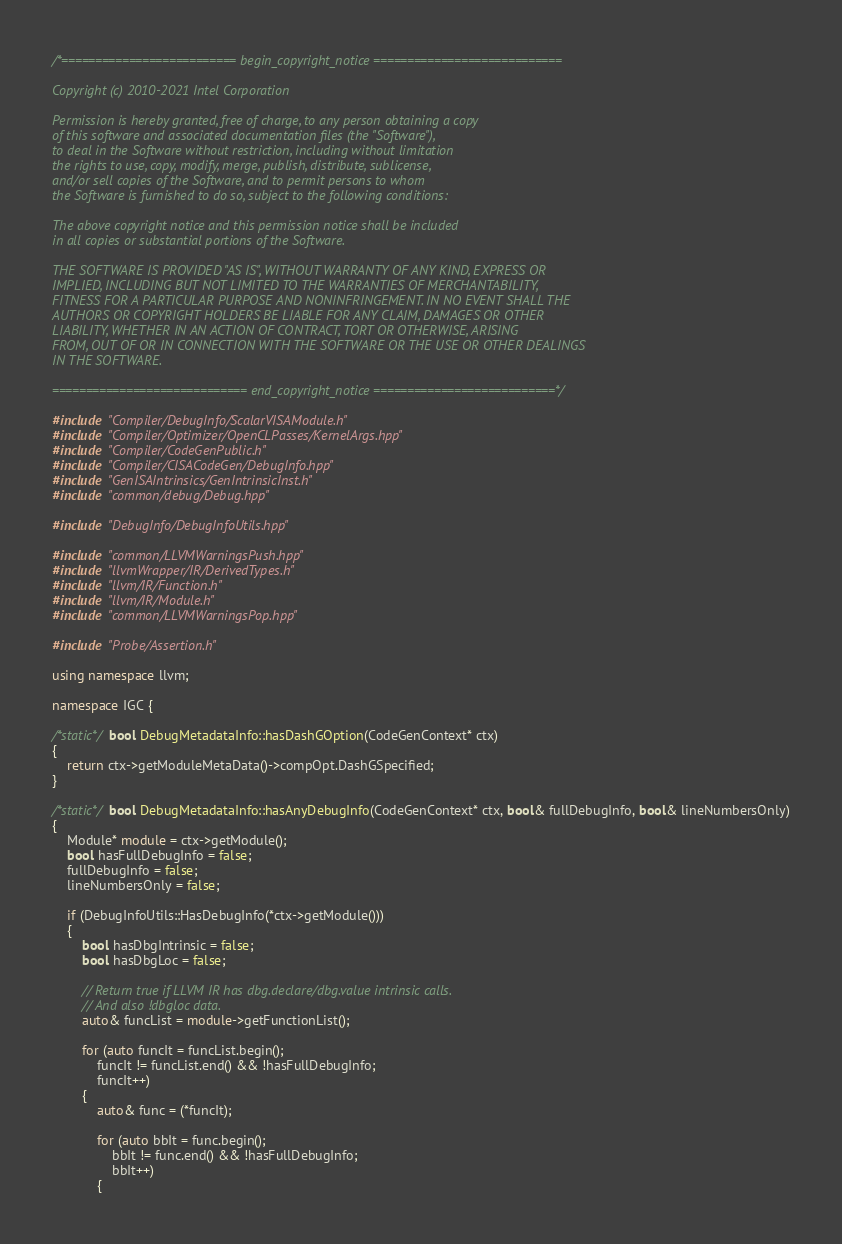Convert code to text. <code><loc_0><loc_0><loc_500><loc_500><_C++_>/*========================== begin_copyright_notice ============================

Copyright (c) 2010-2021 Intel Corporation

Permission is hereby granted, free of charge, to any person obtaining a copy
of this software and associated documentation files (the "Software"),
to deal in the Software without restriction, including without limitation
the rights to use, copy, modify, merge, publish, distribute, sublicense,
and/or sell copies of the Software, and to permit persons to whom
the Software is furnished to do so, subject to the following conditions:

The above copyright notice and this permission notice shall be included
in all copies or substantial portions of the Software.

THE SOFTWARE IS PROVIDED "AS IS", WITHOUT WARRANTY OF ANY KIND, EXPRESS OR
IMPLIED, INCLUDING BUT NOT LIMITED TO THE WARRANTIES OF MERCHANTABILITY,
FITNESS FOR A PARTICULAR PURPOSE AND NONINFRINGEMENT. IN NO EVENT SHALL THE
AUTHORS OR COPYRIGHT HOLDERS BE LIABLE FOR ANY CLAIM, DAMAGES OR OTHER
LIABILITY, WHETHER IN AN ACTION OF CONTRACT, TORT OR OTHERWISE, ARISING
FROM, OUT OF OR IN CONNECTION WITH THE SOFTWARE OR THE USE OR OTHER DEALINGS
IN THE SOFTWARE.

============================= end_copyright_notice ===========================*/

#include "Compiler/DebugInfo/ScalarVISAModule.h"
#include "Compiler/Optimizer/OpenCLPasses/KernelArgs.hpp"
#include "Compiler/CodeGenPublic.h"
#include "Compiler/CISACodeGen/DebugInfo.hpp"
#include "GenISAIntrinsics/GenIntrinsicInst.h"
#include "common/debug/Debug.hpp"

#include "DebugInfo/DebugInfoUtils.hpp"

#include "common/LLVMWarningsPush.hpp"
#include "llvmWrapper/IR/DerivedTypes.h"
#include "llvm/IR/Function.h"
#include "llvm/IR/Module.h"
#include "common/LLVMWarningsPop.hpp"

#include "Probe/Assertion.h"

using namespace llvm;

namespace IGC {

/*static*/ bool DebugMetadataInfo::hasDashGOption(CodeGenContext* ctx)
{
    return ctx->getModuleMetaData()->compOpt.DashGSpecified;
}

/*static*/ bool DebugMetadataInfo::hasAnyDebugInfo(CodeGenContext* ctx, bool& fullDebugInfo, bool& lineNumbersOnly)
{
    Module* module = ctx->getModule();
    bool hasFullDebugInfo = false;
    fullDebugInfo = false;
    lineNumbersOnly = false;

    if (DebugInfoUtils::HasDebugInfo(*ctx->getModule()))
    {
        bool hasDbgIntrinsic = false;
        bool hasDbgLoc = false;

        // Return true if LLVM IR has dbg.declare/dbg.value intrinsic calls.
        // And also !dbgloc data.
        auto& funcList = module->getFunctionList();

        for (auto funcIt = funcList.begin();
            funcIt != funcList.end() && !hasFullDebugInfo;
            funcIt++)
        {
            auto& func = (*funcIt);

            for (auto bbIt = func.begin();
                bbIt != func.end() && !hasFullDebugInfo;
                bbIt++)
            {</code> 